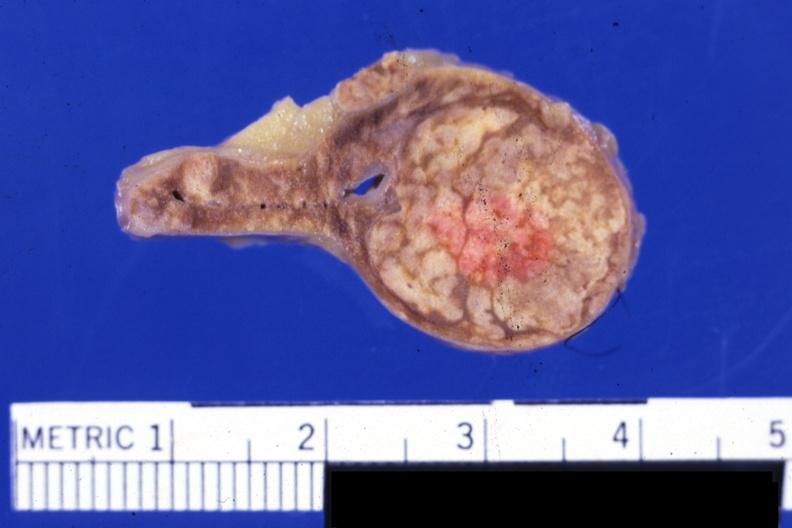what is present?
Answer the question using a single word or phrase. Endocrine 